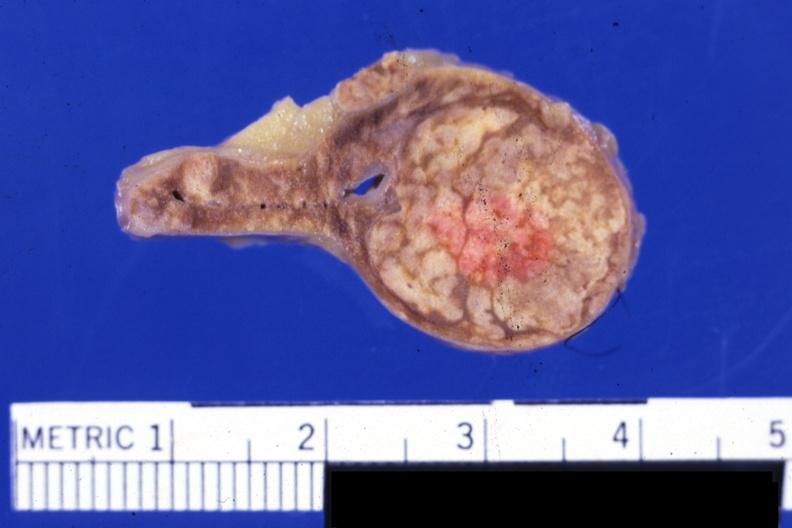what is present?
Answer the question using a single word or phrase. Endocrine 